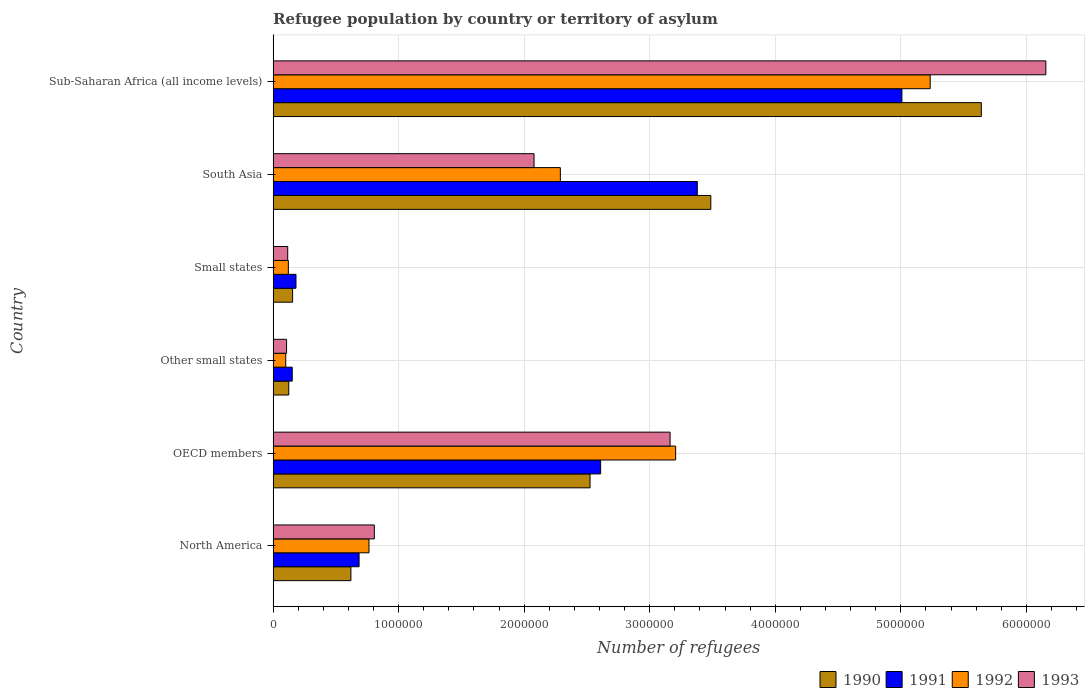How many groups of bars are there?
Your response must be concise. 6. Are the number of bars on each tick of the Y-axis equal?
Ensure brevity in your answer.  Yes. How many bars are there on the 4th tick from the top?
Offer a terse response. 4. In how many cases, is the number of bars for a given country not equal to the number of legend labels?
Keep it short and to the point. 0. What is the number of refugees in 1993 in Small states?
Offer a very short reply. 1.16e+05. Across all countries, what is the maximum number of refugees in 1993?
Provide a short and direct response. 6.16e+06. Across all countries, what is the minimum number of refugees in 1993?
Make the answer very short. 1.07e+05. In which country was the number of refugees in 1993 maximum?
Make the answer very short. Sub-Saharan Africa (all income levels). In which country was the number of refugees in 1990 minimum?
Ensure brevity in your answer.  Other small states. What is the total number of refugees in 1992 in the graph?
Offer a very short reply. 1.17e+07. What is the difference between the number of refugees in 1990 in North America and that in OECD members?
Provide a succinct answer. -1.91e+06. What is the difference between the number of refugees in 1991 in Other small states and the number of refugees in 1990 in North America?
Your response must be concise. -4.67e+05. What is the average number of refugees in 1991 per country?
Provide a short and direct response. 2.00e+06. What is the difference between the number of refugees in 1993 and number of refugees in 1992 in Sub-Saharan Africa (all income levels)?
Offer a very short reply. 9.21e+05. What is the ratio of the number of refugees in 1993 in Small states to that in South Asia?
Keep it short and to the point. 0.06. Is the number of refugees in 1993 in OECD members less than that in Small states?
Your answer should be compact. No. Is the difference between the number of refugees in 1993 in Other small states and Sub-Saharan Africa (all income levels) greater than the difference between the number of refugees in 1992 in Other small states and Sub-Saharan Africa (all income levels)?
Offer a terse response. No. What is the difference between the highest and the second highest number of refugees in 1992?
Your answer should be very brief. 2.03e+06. What is the difference between the highest and the lowest number of refugees in 1993?
Your answer should be very brief. 6.05e+06. Is the sum of the number of refugees in 1991 in Small states and Sub-Saharan Africa (all income levels) greater than the maximum number of refugees in 1993 across all countries?
Provide a short and direct response. No. What does the 3rd bar from the bottom in OECD members represents?
Offer a very short reply. 1992. Is it the case that in every country, the sum of the number of refugees in 1992 and number of refugees in 1993 is greater than the number of refugees in 1991?
Your answer should be compact. Yes. How many bars are there?
Give a very brief answer. 24. Are all the bars in the graph horizontal?
Provide a succinct answer. Yes. How many countries are there in the graph?
Offer a very short reply. 6. Does the graph contain any zero values?
Make the answer very short. No. Does the graph contain grids?
Your answer should be compact. Yes. What is the title of the graph?
Your answer should be compact. Refugee population by country or territory of asylum. Does "1998" appear as one of the legend labels in the graph?
Keep it short and to the point. No. What is the label or title of the X-axis?
Offer a terse response. Number of refugees. What is the label or title of the Y-axis?
Your answer should be very brief. Country. What is the Number of refugees in 1990 in North America?
Ensure brevity in your answer.  6.20e+05. What is the Number of refugees of 1991 in North America?
Keep it short and to the point. 6.85e+05. What is the Number of refugees of 1992 in North America?
Offer a very short reply. 7.64e+05. What is the Number of refugees in 1993 in North America?
Keep it short and to the point. 8.06e+05. What is the Number of refugees of 1990 in OECD members?
Keep it short and to the point. 2.52e+06. What is the Number of refugees in 1991 in OECD members?
Make the answer very short. 2.61e+06. What is the Number of refugees in 1992 in OECD members?
Keep it short and to the point. 3.21e+06. What is the Number of refugees in 1993 in OECD members?
Your answer should be compact. 3.16e+06. What is the Number of refugees in 1990 in Other small states?
Make the answer very short. 1.25e+05. What is the Number of refugees in 1991 in Other small states?
Offer a terse response. 1.52e+05. What is the Number of refugees of 1992 in Other small states?
Offer a very short reply. 1.00e+05. What is the Number of refugees in 1993 in Other small states?
Ensure brevity in your answer.  1.07e+05. What is the Number of refugees in 1990 in Small states?
Give a very brief answer. 1.55e+05. What is the Number of refugees in 1991 in Small states?
Your answer should be compact. 1.82e+05. What is the Number of refugees of 1992 in Small states?
Give a very brief answer. 1.21e+05. What is the Number of refugees in 1993 in Small states?
Your response must be concise. 1.16e+05. What is the Number of refugees of 1990 in South Asia?
Give a very brief answer. 3.49e+06. What is the Number of refugees in 1991 in South Asia?
Offer a very short reply. 3.38e+06. What is the Number of refugees of 1992 in South Asia?
Your answer should be compact. 2.29e+06. What is the Number of refugees in 1993 in South Asia?
Offer a terse response. 2.08e+06. What is the Number of refugees in 1990 in Sub-Saharan Africa (all income levels)?
Provide a short and direct response. 5.64e+06. What is the Number of refugees in 1991 in Sub-Saharan Africa (all income levels)?
Provide a succinct answer. 5.01e+06. What is the Number of refugees of 1992 in Sub-Saharan Africa (all income levels)?
Ensure brevity in your answer.  5.23e+06. What is the Number of refugees in 1993 in Sub-Saharan Africa (all income levels)?
Provide a short and direct response. 6.16e+06. Across all countries, what is the maximum Number of refugees in 1990?
Give a very brief answer. 5.64e+06. Across all countries, what is the maximum Number of refugees in 1991?
Give a very brief answer. 5.01e+06. Across all countries, what is the maximum Number of refugees in 1992?
Keep it short and to the point. 5.23e+06. Across all countries, what is the maximum Number of refugees of 1993?
Ensure brevity in your answer.  6.16e+06. Across all countries, what is the minimum Number of refugees in 1990?
Your response must be concise. 1.25e+05. Across all countries, what is the minimum Number of refugees of 1991?
Keep it short and to the point. 1.52e+05. Across all countries, what is the minimum Number of refugees of 1992?
Provide a succinct answer. 1.00e+05. Across all countries, what is the minimum Number of refugees of 1993?
Offer a terse response. 1.07e+05. What is the total Number of refugees in 1990 in the graph?
Make the answer very short. 1.26e+07. What is the total Number of refugees of 1991 in the graph?
Provide a short and direct response. 1.20e+07. What is the total Number of refugees of 1992 in the graph?
Offer a very short reply. 1.17e+07. What is the total Number of refugees of 1993 in the graph?
Offer a very short reply. 1.24e+07. What is the difference between the Number of refugees of 1990 in North America and that in OECD members?
Your answer should be very brief. -1.91e+06. What is the difference between the Number of refugees of 1991 in North America and that in OECD members?
Provide a succinct answer. -1.92e+06. What is the difference between the Number of refugees in 1992 in North America and that in OECD members?
Keep it short and to the point. -2.44e+06. What is the difference between the Number of refugees in 1993 in North America and that in OECD members?
Provide a short and direct response. -2.36e+06. What is the difference between the Number of refugees of 1990 in North America and that in Other small states?
Your response must be concise. 4.95e+05. What is the difference between the Number of refugees in 1991 in North America and that in Other small states?
Keep it short and to the point. 5.33e+05. What is the difference between the Number of refugees of 1992 in North America and that in Other small states?
Keep it short and to the point. 6.63e+05. What is the difference between the Number of refugees of 1993 in North America and that in Other small states?
Provide a short and direct response. 6.99e+05. What is the difference between the Number of refugees in 1990 in North America and that in Small states?
Provide a succinct answer. 4.64e+05. What is the difference between the Number of refugees in 1991 in North America and that in Small states?
Make the answer very short. 5.03e+05. What is the difference between the Number of refugees in 1992 in North America and that in Small states?
Give a very brief answer. 6.42e+05. What is the difference between the Number of refugees in 1993 in North America and that in Small states?
Your answer should be compact. 6.90e+05. What is the difference between the Number of refugees in 1990 in North America and that in South Asia?
Keep it short and to the point. -2.87e+06. What is the difference between the Number of refugees in 1991 in North America and that in South Asia?
Your response must be concise. -2.69e+06. What is the difference between the Number of refugees of 1992 in North America and that in South Asia?
Make the answer very short. -1.52e+06. What is the difference between the Number of refugees of 1993 in North America and that in South Asia?
Give a very brief answer. -1.27e+06. What is the difference between the Number of refugees of 1990 in North America and that in Sub-Saharan Africa (all income levels)?
Your answer should be very brief. -5.02e+06. What is the difference between the Number of refugees in 1991 in North America and that in Sub-Saharan Africa (all income levels)?
Provide a short and direct response. -4.32e+06. What is the difference between the Number of refugees of 1992 in North America and that in Sub-Saharan Africa (all income levels)?
Ensure brevity in your answer.  -4.47e+06. What is the difference between the Number of refugees in 1993 in North America and that in Sub-Saharan Africa (all income levels)?
Offer a very short reply. -5.35e+06. What is the difference between the Number of refugees of 1990 in OECD members and that in Other small states?
Ensure brevity in your answer.  2.40e+06. What is the difference between the Number of refugees in 1991 in OECD members and that in Other small states?
Give a very brief answer. 2.46e+06. What is the difference between the Number of refugees in 1992 in OECD members and that in Other small states?
Provide a short and direct response. 3.11e+06. What is the difference between the Number of refugees in 1993 in OECD members and that in Other small states?
Offer a terse response. 3.06e+06. What is the difference between the Number of refugees in 1990 in OECD members and that in Small states?
Provide a succinct answer. 2.37e+06. What is the difference between the Number of refugees in 1991 in OECD members and that in Small states?
Your answer should be compact. 2.43e+06. What is the difference between the Number of refugees of 1992 in OECD members and that in Small states?
Offer a terse response. 3.09e+06. What is the difference between the Number of refugees in 1993 in OECD members and that in Small states?
Make the answer very short. 3.05e+06. What is the difference between the Number of refugees in 1990 in OECD members and that in South Asia?
Make the answer very short. -9.62e+05. What is the difference between the Number of refugees in 1991 in OECD members and that in South Asia?
Your answer should be very brief. -7.70e+05. What is the difference between the Number of refugees in 1992 in OECD members and that in South Asia?
Provide a short and direct response. 9.19e+05. What is the difference between the Number of refugees in 1993 in OECD members and that in South Asia?
Ensure brevity in your answer.  1.08e+06. What is the difference between the Number of refugees in 1990 in OECD members and that in Sub-Saharan Africa (all income levels)?
Keep it short and to the point. -3.12e+06. What is the difference between the Number of refugees in 1991 in OECD members and that in Sub-Saharan Africa (all income levels)?
Give a very brief answer. -2.40e+06. What is the difference between the Number of refugees in 1992 in OECD members and that in Sub-Saharan Africa (all income levels)?
Provide a short and direct response. -2.03e+06. What is the difference between the Number of refugees of 1993 in OECD members and that in Sub-Saharan Africa (all income levels)?
Your answer should be very brief. -2.99e+06. What is the difference between the Number of refugees in 1990 in Other small states and that in Small states?
Keep it short and to the point. -3.07e+04. What is the difference between the Number of refugees of 1991 in Other small states and that in Small states?
Your response must be concise. -3.00e+04. What is the difference between the Number of refugees in 1992 in Other small states and that in Small states?
Provide a succinct answer. -2.09e+04. What is the difference between the Number of refugees in 1993 in Other small states and that in Small states?
Ensure brevity in your answer.  -9084. What is the difference between the Number of refugees of 1990 in Other small states and that in South Asia?
Your answer should be compact. -3.36e+06. What is the difference between the Number of refugees in 1991 in Other small states and that in South Asia?
Provide a succinct answer. -3.23e+06. What is the difference between the Number of refugees of 1992 in Other small states and that in South Asia?
Make the answer very short. -2.19e+06. What is the difference between the Number of refugees in 1993 in Other small states and that in South Asia?
Provide a succinct answer. -1.97e+06. What is the difference between the Number of refugees of 1990 in Other small states and that in Sub-Saharan Africa (all income levels)?
Your response must be concise. -5.52e+06. What is the difference between the Number of refugees of 1991 in Other small states and that in Sub-Saharan Africa (all income levels)?
Provide a short and direct response. -4.86e+06. What is the difference between the Number of refugees in 1992 in Other small states and that in Sub-Saharan Africa (all income levels)?
Make the answer very short. -5.13e+06. What is the difference between the Number of refugees in 1993 in Other small states and that in Sub-Saharan Africa (all income levels)?
Offer a terse response. -6.05e+06. What is the difference between the Number of refugees in 1990 in Small states and that in South Asia?
Your response must be concise. -3.33e+06. What is the difference between the Number of refugees in 1991 in Small states and that in South Asia?
Provide a succinct answer. -3.20e+06. What is the difference between the Number of refugees of 1992 in Small states and that in South Asia?
Offer a very short reply. -2.17e+06. What is the difference between the Number of refugees of 1993 in Small states and that in South Asia?
Your response must be concise. -1.96e+06. What is the difference between the Number of refugees in 1990 in Small states and that in Sub-Saharan Africa (all income levels)?
Your answer should be very brief. -5.49e+06. What is the difference between the Number of refugees in 1991 in Small states and that in Sub-Saharan Africa (all income levels)?
Provide a succinct answer. -4.83e+06. What is the difference between the Number of refugees in 1992 in Small states and that in Sub-Saharan Africa (all income levels)?
Your response must be concise. -5.11e+06. What is the difference between the Number of refugees in 1993 in Small states and that in Sub-Saharan Africa (all income levels)?
Keep it short and to the point. -6.04e+06. What is the difference between the Number of refugees in 1990 in South Asia and that in Sub-Saharan Africa (all income levels)?
Keep it short and to the point. -2.15e+06. What is the difference between the Number of refugees in 1991 in South Asia and that in Sub-Saharan Africa (all income levels)?
Offer a very short reply. -1.63e+06. What is the difference between the Number of refugees in 1992 in South Asia and that in Sub-Saharan Africa (all income levels)?
Your answer should be compact. -2.95e+06. What is the difference between the Number of refugees of 1993 in South Asia and that in Sub-Saharan Africa (all income levels)?
Keep it short and to the point. -4.08e+06. What is the difference between the Number of refugees of 1990 in North America and the Number of refugees of 1991 in OECD members?
Your answer should be very brief. -1.99e+06. What is the difference between the Number of refugees in 1990 in North America and the Number of refugees in 1992 in OECD members?
Your response must be concise. -2.59e+06. What is the difference between the Number of refugees of 1990 in North America and the Number of refugees of 1993 in OECD members?
Your answer should be compact. -2.54e+06. What is the difference between the Number of refugees in 1991 in North America and the Number of refugees in 1992 in OECD members?
Keep it short and to the point. -2.52e+06. What is the difference between the Number of refugees of 1991 in North America and the Number of refugees of 1993 in OECD members?
Provide a short and direct response. -2.48e+06. What is the difference between the Number of refugees in 1992 in North America and the Number of refugees in 1993 in OECD members?
Provide a short and direct response. -2.40e+06. What is the difference between the Number of refugees of 1990 in North America and the Number of refugees of 1991 in Other small states?
Give a very brief answer. 4.67e+05. What is the difference between the Number of refugees in 1990 in North America and the Number of refugees in 1992 in Other small states?
Provide a succinct answer. 5.19e+05. What is the difference between the Number of refugees in 1990 in North America and the Number of refugees in 1993 in Other small states?
Make the answer very short. 5.13e+05. What is the difference between the Number of refugees in 1991 in North America and the Number of refugees in 1992 in Other small states?
Your answer should be very brief. 5.84e+05. What is the difference between the Number of refugees in 1991 in North America and the Number of refugees in 1993 in Other small states?
Your response must be concise. 5.78e+05. What is the difference between the Number of refugees in 1992 in North America and the Number of refugees in 1993 in Other small states?
Keep it short and to the point. 6.57e+05. What is the difference between the Number of refugees of 1990 in North America and the Number of refugees of 1991 in Small states?
Your response must be concise. 4.37e+05. What is the difference between the Number of refugees in 1990 in North America and the Number of refugees in 1992 in Small states?
Give a very brief answer. 4.98e+05. What is the difference between the Number of refugees in 1990 in North America and the Number of refugees in 1993 in Small states?
Offer a terse response. 5.04e+05. What is the difference between the Number of refugees in 1991 in North America and the Number of refugees in 1992 in Small states?
Offer a very short reply. 5.63e+05. What is the difference between the Number of refugees in 1991 in North America and the Number of refugees in 1993 in Small states?
Provide a succinct answer. 5.69e+05. What is the difference between the Number of refugees in 1992 in North America and the Number of refugees in 1993 in Small states?
Offer a very short reply. 6.48e+05. What is the difference between the Number of refugees of 1990 in North America and the Number of refugees of 1991 in South Asia?
Offer a terse response. -2.76e+06. What is the difference between the Number of refugees of 1990 in North America and the Number of refugees of 1992 in South Asia?
Offer a terse response. -1.67e+06. What is the difference between the Number of refugees in 1990 in North America and the Number of refugees in 1993 in South Asia?
Give a very brief answer. -1.46e+06. What is the difference between the Number of refugees in 1991 in North America and the Number of refugees in 1992 in South Asia?
Offer a terse response. -1.60e+06. What is the difference between the Number of refugees of 1991 in North America and the Number of refugees of 1993 in South Asia?
Your answer should be compact. -1.39e+06. What is the difference between the Number of refugees in 1992 in North America and the Number of refugees in 1993 in South Asia?
Your answer should be compact. -1.31e+06. What is the difference between the Number of refugees of 1990 in North America and the Number of refugees of 1991 in Sub-Saharan Africa (all income levels)?
Your answer should be compact. -4.39e+06. What is the difference between the Number of refugees of 1990 in North America and the Number of refugees of 1992 in Sub-Saharan Africa (all income levels)?
Offer a very short reply. -4.61e+06. What is the difference between the Number of refugees in 1990 in North America and the Number of refugees in 1993 in Sub-Saharan Africa (all income levels)?
Provide a short and direct response. -5.54e+06. What is the difference between the Number of refugees of 1991 in North America and the Number of refugees of 1992 in Sub-Saharan Africa (all income levels)?
Offer a very short reply. -4.55e+06. What is the difference between the Number of refugees in 1991 in North America and the Number of refugees in 1993 in Sub-Saharan Africa (all income levels)?
Make the answer very short. -5.47e+06. What is the difference between the Number of refugees in 1992 in North America and the Number of refugees in 1993 in Sub-Saharan Africa (all income levels)?
Offer a terse response. -5.39e+06. What is the difference between the Number of refugees in 1990 in OECD members and the Number of refugees in 1991 in Other small states?
Your answer should be compact. 2.37e+06. What is the difference between the Number of refugees in 1990 in OECD members and the Number of refugees in 1992 in Other small states?
Provide a succinct answer. 2.42e+06. What is the difference between the Number of refugees in 1990 in OECD members and the Number of refugees in 1993 in Other small states?
Give a very brief answer. 2.42e+06. What is the difference between the Number of refugees in 1991 in OECD members and the Number of refugees in 1992 in Other small states?
Your response must be concise. 2.51e+06. What is the difference between the Number of refugees of 1991 in OECD members and the Number of refugees of 1993 in Other small states?
Provide a short and direct response. 2.50e+06. What is the difference between the Number of refugees of 1992 in OECD members and the Number of refugees of 1993 in Other small states?
Give a very brief answer. 3.10e+06. What is the difference between the Number of refugees in 1990 in OECD members and the Number of refugees in 1991 in Small states?
Give a very brief answer. 2.34e+06. What is the difference between the Number of refugees in 1990 in OECD members and the Number of refugees in 1992 in Small states?
Make the answer very short. 2.40e+06. What is the difference between the Number of refugees of 1990 in OECD members and the Number of refugees of 1993 in Small states?
Give a very brief answer. 2.41e+06. What is the difference between the Number of refugees of 1991 in OECD members and the Number of refugees of 1992 in Small states?
Your answer should be very brief. 2.49e+06. What is the difference between the Number of refugees of 1991 in OECD members and the Number of refugees of 1993 in Small states?
Give a very brief answer. 2.49e+06. What is the difference between the Number of refugees in 1992 in OECD members and the Number of refugees in 1993 in Small states?
Your answer should be compact. 3.09e+06. What is the difference between the Number of refugees in 1990 in OECD members and the Number of refugees in 1991 in South Asia?
Your answer should be very brief. -8.54e+05. What is the difference between the Number of refugees of 1990 in OECD members and the Number of refugees of 1992 in South Asia?
Offer a very short reply. 2.37e+05. What is the difference between the Number of refugees in 1990 in OECD members and the Number of refugees in 1993 in South Asia?
Ensure brevity in your answer.  4.46e+05. What is the difference between the Number of refugees in 1991 in OECD members and the Number of refugees in 1992 in South Asia?
Offer a terse response. 3.21e+05. What is the difference between the Number of refugees of 1991 in OECD members and the Number of refugees of 1993 in South Asia?
Keep it short and to the point. 5.30e+05. What is the difference between the Number of refugees in 1992 in OECD members and the Number of refugees in 1993 in South Asia?
Provide a short and direct response. 1.13e+06. What is the difference between the Number of refugees in 1990 in OECD members and the Number of refugees in 1991 in Sub-Saharan Africa (all income levels)?
Provide a short and direct response. -2.48e+06. What is the difference between the Number of refugees of 1990 in OECD members and the Number of refugees of 1992 in Sub-Saharan Africa (all income levels)?
Offer a terse response. -2.71e+06. What is the difference between the Number of refugees of 1990 in OECD members and the Number of refugees of 1993 in Sub-Saharan Africa (all income levels)?
Ensure brevity in your answer.  -3.63e+06. What is the difference between the Number of refugees of 1991 in OECD members and the Number of refugees of 1992 in Sub-Saharan Africa (all income levels)?
Offer a very short reply. -2.63e+06. What is the difference between the Number of refugees of 1991 in OECD members and the Number of refugees of 1993 in Sub-Saharan Africa (all income levels)?
Provide a succinct answer. -3.55e+06. What is the difference between the Number of refugees of 1992 in OECD members and the Number of refugees of 1993 in Sub-Saharan Africa (all income levels)?
Provide a succinct answer. -2.95e+06. What is the difference between the Number of refugees in 1990 in Other small states and the Number of refugees in 1991 in Small states?
Keep it short and to the point. -5.76e+04. What is the difference between the Number of refugees in 1990 in Other small states and the Number of refugees in 1992 in Small states?
Provide a succinct answer. 3271. What is the difference between the Number of refugees of 1990 in Other small states and the Number of refugees of 1993 in Small states?
Provide a succinct answer. 8450. What is the difference between the Number of refugees of 1991 in Other small states and the Number of refugees of 1992 in Small states?
Your answer should be very brief. 3.09e+04. What is the difference between the Number of refugees in 1991 in Other small states and the Number of refugees in 1993 in Small states?
Your answer should be very brief. 3.61e+04. What is the difference between the Number of refugees in 1992 in Other small states and the Number of refugees in 1993 in Small states?
Offer a very short reply. -1.57e+04. What is the difference between the Number of refugees in 1990 in Other small states and the Number of refugees in 1991 in South Asia?
Offer a terse response. -3.25e+06. What is the difference between the Number of refugees in 1990 in Other small states and the Number of refugees in 1992 in South Asia?
Your answer should be very brief. -2.16e+06. What is the difference between the Number of refugees of 1990 in Other small states and the Number of refugees of 1993 in South Asia?
Your answer should be very brief. -1.95e+06. What is the difference between the Number of refugees in 1991 in Other small states and the Number of refugees in 1992 in South Asia?
Offer a terse response. -2.14e+06. What is the difference between the Number of refugees in 1991 in Other small states and the Number of refugees in 1993 in South Asia?
Offer a terse response. -1.93e+06. What is the difference between the Number of refugees of 1992 in Other small states and the Number of refugees of 1993 in South Asia?
Make the answer very short. -1.98e+06. What is the difference between the Number of refugees in 1990 in Other small states and the Number of refugees in 1991 in Sub-Saharan Africa (all income levels)?
Your answer should be compact. -4.88e+06. What is the difference between the Number of refugees in 1990 in Other small states and the Number of refugees in 1992 in Sub-Saharan Africa (all income levels)?
Give a very brief answer. -5.11e+06. What is the difference between the Number of refugees in 1990 in Other small states and the Number of refugees in 1993 in Sub-Saharan Africa (all income levels)?
Offer a very short reply. -6.03e+06. What is the difference between the Number of refugees in 1991 in Other small states and the Number of refugees in 1992 in Sub-Saharan Africa (all income levels)?
Your answer should be very brief. -5.08e+06. What is the difference between the Number of refugees of 1991 in Other small states and the Number of refugees of 1993 in Sub-Saharan Africa (all income levels)?
Your response must be concise. -6.00e+06. What is the difference between the Number of refugees of 1992 in Other small states and the Number of refugees of 1993 in Sub-Saharan Africa (all income levels)?
Give a very brief answer. -6.06e+06. What is the difference between the Number of refugees of 1990 in Small states and the Number of refugees of 1991 in South Asia?
Provide a succinct answer. -3.22e+06. What is the difference between the Number of refugees in 1990 in Small states and the Number of refugees in 1992 in South Asia?
Offer a very short reply. -2.13e+06. What is the difference between the Number of refugees in 1990 in Small states and the Number of refugees in 1993 in South Asia?
Keep it short and to the point. -1.92e+06. What is the difference between the Number of refugees in 1991 in Small states and the Number of refugees in 1992 in South Asia?
Offer a very short reply. -2.11e+06. What is the difference between the Number of refugees of 1991 in Small states and the Number of refugees of 1993 in South Asia?
Provide a succinct answer. -1.90e+06. What is the difference between the Number of refugees in 1992 in Small states and the Number of refugees in 1993 in South Asia?
Your response must be concise. -1.96e+06. What is the difference between the Number of refugees in 1990 in Small states and the Number of refugees in 1991 in Sub-Saharan Africa (all income levels)?
Your answer should be very brief. -4.85e+06. What is the difference between the Number of refugees in 1990 in Small states and the Number of refugees in 1992 in Sub-Saharan Africa (all income levels)?
Offer a very short reply. -5.08e+06. What is the difference between the Number of refugees of 1990 in Small states and the Number of refugees of 1993 in Sub-Saharan Africa (all income levels)?
Make the answer very short. -6.00e+06. What is the difference between the Number of refugees of 1991 in Small states and the Number of refugees of 1992 in Sub-Saharan Africa (all income levels)?
Provide a short and direct response. -5.05e+06. What is the difference between the Number of refugees in 1991 in Small states and the Number of refugees in 1993 in Sub-Saharan Africa (all income levels)?
Provide a succinct answer. -5.97e+06. What is the difference between the Number of refugees in 1992 in Small states and the Number of refugees in 1993 in Sub-Saharan Africa (all income levels)?
Provide a short and direct response. -6.03e+06. What is the difference between the Number of refugees in 1990 in South Asia and the Number of refugees in 1991 in Sub-Saharan Africa (all income levels)?
Keep it short and to the point. -1.52e+06. What is the difference between the Number of refugees of 1990 in South Asia and the Number of refugees of 1992 in Sub-Saharan Africa (all income levels)?
Your answer should be compact. -1.75e+06. What is the difference between the Number of refugees in 1990 in South Asia and the Number of refugees in 1993 in Sub-Saharan Africa (all income levels)?
Provide a short and direct response. -2.67e+06. What is the difference between the Number of refugees in 1991 in South Asia and the Number of refugees in 1992 in Sub-Saharan Africa (all income levels)?
Keep it short and to the point. -1.86e+06. What is the difference between the Number of refugees of 1991 in South Asia and the Number of refugees of 1993 in Sub-Saharan Africa (all income levels)?
Provide a short and direct response. -2.78e+06. What is the difference between the Number of refugees in 1992 in South Asia and the Number of refugees in 1993 in Sub-Saharan Africa (all income levels)?
Your answer should be compact. -3.87e+06. What is the average Number of refugees of 1990 per country?
Give a very brief answer. 2.09e+06. What is the average Number of refugees in 1991 per country?
Offer a terse response. 2.00e+06. What is the average Number of refugees in 1992 per country?
Offer a terse response. 1.95e+06. What is the average Number of refugees in 1993 per country?
Ensure brevity in your answer.  2.07e+06. What is the difference between the Number of refugees in 1990 and Number of refugees in 1991 in North America?
Offer a very short reply. -6.52e+04. What is the difference between the Number of refugees of 1990 and Number of refugees of 1992 in North America?
Offer a terse response. -1.44e+05. What is the difference between the Number of refugees in 1990 and Number of refugees in 1993 in North America?
Your response must be concise. -1.87e+05. What is the difference between the Number of refugees of 1991 and Number of refugees of 1992 in North America?
Your response must be concise. -7.89e+04. What is the difference between the Number of refugees in 1991 and Number of refugees in 1993 in North America?
Offer a terse response. -1.22e+05. What is the difference between the Number of refugees of 1992 and Number of refugees of 1993 in North America?
Provide a short and direct response. -4.26e+04. What is the difference between the Number of refugees in 1990 and Number of refugees in 1991 in OECD members?
Provide a succinct answer. -8.42e+04. What is the difference between the Number of refugees of 1990 and Number of refugees of 1992 in OECD members?
Provide a succinct answer. -6.82e+05. What is the difference between the Number of refugees of 1990 and Number of refugees of 1993 in OECD members?
Provide a short and direct response. -6.37e+05. What is the difference between the Number of refugees in 1991 and Number of refugees in 1992 in OECD members?
Your answer should be very brief. -5.98e+05. What is the difference between the Number of refugees in 1991 and Number of refugees in 1993 in OECD members?
Keep it short and to the point. -5.53e+05. What is the difference between the Number of refugees in 1992 and Number of refugees in 1993 in OECD members?
Your response must be concise. 4.45e+04. What is the difference between the Number of refugees in 1990 and Number of refugees in 1991 in Other small states?
Keep it short and to the point. -2.76e+04. What is the difference between the Number of refugees of 1990 and Number of refugees of 1992 in Other small states?
Offer a terse response. 2.41e+04. What is the difference between the Number of refugees of 1990 and Number of refugees of 1993 in Other small states?
Offer a very short reply. 1.75e+04. What is the difference between the Number of refugees in 1991 and Number of refugees in 1992 in Other small states?
Your answer should be compact. 5.18e+04. What is the difference between the Number of refugees of 1991 and Number of refugees of 1993 in Other small states?
Your answer should be very brief. 4.52e+04. What is the difference between the Number of refugees in 1992 and Number of refugees in 1993 in Other small states?
Offer a terse response. -6604. What is the difference between the Number of refugees in 1990 and Number of refugees in 1991 in Small states?
Make the answer very short. -2.70e+04. What is the difference between the Number of refugees in 1990 and Number of refugees in 1992 in Small states?
Your response must be concise. 3.39e+04. What is the difference between the Number of refugees in 1990 and Number of refugees in 1993 in Small states?
Your answer should be compact. 3.91e+04. What is the difference between the Number of refugees of 1991 and Number of refugees of 1992 in Small states?
Provide a short and direct response. 6.09e+04. What is the difference between the Number of refugees in 1991 and Number of refugees in 1993 in Small states?
Offer a very short reply. 6.61e+04. What is the difference between the Number of refugees in 1992 and Number of refugees in 1993 in Small states?
Your answer should be compact. 5179. What is the difference between the Number of refugees in 1990 and Number of refugees in 1991 in South Asia?
Give a very brief answer. 1.08e+05. What is the difference between the Number of refugees of 1990 and Number of refugees of 1992 in South Asia?
Your response must be concise. 1.20e+06. What is the difference between the Number of refugees in 1990 and Number of refugees in 1993 in South Asia?
Provide a succinct answer. 1.41e+06. What is the difference between the Number of refugees of 1991 and Number of refugees of 1992 in South Asia?
Make the answer very short. 1.09e+06. What is the difference between the Number of refugees of 1991 and Number of refugees of 1993 in South Asia?
Ensure brevity in your answer.  1.30e+06. What is the difference between the Number of refugees in 1992 and Number of refugees in 1993 in South Asia?
Offer a very short reply. 2.10e+05. What is the difference between the Number of refugees in 1990 and Number of refugees in 1991 in Sub-Saharan Africa (all income levels)?
Offer a terse response. 6.33e+05. What is the difference between the Number of refugees of 1990 and Number of refugees of 1992 in Sub-Saharan Africa (all income levels)?
Offer a terse response. 4.07e+05. What is the difference between the Number of refugees of 1990 and Number of refugees of 1993 in Sub-Saharan Africa (all income levels)?
Your response must be concise. -5.14e+05. What is the difference between the Number of refugees in 1991 and Number of refugees in 1992 in Sub-Saharan Africa (all income levels)?
Offer a very short reply. -2.25e+05. What is the difference between the Number of refugees in 1991 and Number of refugees in 1993 in Sub-Saharan Africa (all income levels)?
Give a very brief answer. -1.15e+06. What is the difference between the Number of refugees of 1992 and Number of refugees of 1993 in Sub-Saharan Africa (all income levels)?
Your answer should be very brief. -9.21e+05. What is the ratio of the Number of refugees of 1990 in North America to that in OECD members?
Your response must be concise. 0.25. What is the ratio of the Number of refugees of 1991 in North America to that in OECD members?
Your answer should be compact. 0.26. What is the ratio of the Number of refugees in 1992 in North America to that in OECD members?
Give a very brief answer. 0.24. What is the ratio of the Number of refugees in 1993 in North America to that in OECD members?
Provide a short and direct response. 0.26. What is the ratio of the Number of refugees in 1990 in North America to that in Other small states?
Provide a succinct answer. 4.97. What is the ratio of the Number of refugees of 1991 in North America to that in Other small states?
Your response must be concise. 4.5. What is the ratio of the Number of refugees of 1992 in North America to that in Other small states?
Make the answer very short. 7.6. What is the ratio of the Number of refugees of 1993 in North America to that in Other small states?
Provide a succinct answer. 7.53. What is the ratio of the Number of refugees of 1990 in North America to that in Small states?
Provide a short and direct response. 3.99. What is the ratio of the Number of refugees of 1991 in North America to that in Small states?
Provide a succinct answer. 3.76. What is the ratio of the Number of refugees of 1992 in North America to that in Small states?
Your answer should be compact. 6.3. What is the ratio of the Number of refugees in 1993 in North America to that in Small states?
Provide a short and direct response. 6.94. What is the ratio of the Number of refugees in 1990 in North America to that in South Asia?
Your answer should be compact. 0.18. What is the ratio of the Number of refugees in 1991 in North America to that in South Asia?
Provide a short and direct response. 0.2. What is the ratio of the Number of refugees in 1992 in North America to that in South Asia?
Provide a short and direct response. 0.33. What is the ratio of the Number of refugees of 1993 in North America to that in South Asia?
Offer a very short reply. 0.39. What is the ratio of the Number of refugees of 1990 in North America to that in Sub-Saharan Africa (all income levels)?
Your answer should be very brief. 0.11. What is the ratio of the Number of refugees in 1991 in North America to that in Sub-Saharan Africa (all income levels)?
Your answer should be very brief. 0.14. What is the ratio of the Number of refugees in 1992 in North America to that in Sub-Saharan Africa (all income levels)?
Offer a terse response. 0.15. What is the ratio of the Number of refugees in 1993 in North America to that in Sub-Saharan Africa (all income levels)?
Give a very brief answer. 0.13. What is the ratio of the Number of refugees of 1990 in OECD members to that in Other small states?
Provide a succinct answer. 20.27. What is the ratio of the Number of refugees of 1991 in OECD members to that in Other small states?
Offer a very short reply. 17.14. What is the ratio of the Number of refugees in 1992 in OECD members to that in Other small states?
Make the answer very short. 31.93. What is the ratio of the Number of refugees in 1993 in OECD members to that in Other small states?
Keep it short and to the point. 29.54. What is the ratio of the Number of refugees of 1990 in OECD members to that in Small states?
Keep it short and to the point. 16.26. What is the ratio of the Number of refugees in 1991 in OECD members to that in Small states?
Your answer should be compact. 14.32. What is the ratio of the Number of refugees of 1992 in OECD members to that in Small states?
Your response must be concise. 26.43. What is the ratio of the Number of refugees in 1993 in OECD members to that in Small states?
Offer a terse response. 27.23. What is the ratio of the Number of refugees in 1990 in OECD members to that in South Asia?
Keep it short and to the point. 0.72. What is the ratio of the Number of refugees in 1991 in OECD members to that in South Asia?
Offer a terse response. 0.77. What is the ratio of the Number of refugees of 1992 in OECD members to that in South Asia?
Provide a short and direct response. 1.4. What is the ratio of the Number of refugees of 1993 in OECD members to that in South Asia?
Your response must be concise. 1.52. What is the ratio of the Number of refugees of 1990 in OECD members to that in Sub-Saharan Africa (all income levels)?
Your answer should be very brief. 0.45. What is the ratio of the Number of refugees in 1991 in OECD members to that in Sub-Saharan Africa (all income levels)?
Offer a terse response. 0.52. What is the ratio of the Number of refugees of 1992 in OECD members to that in Sub-Saharan Africa (all income levels)?
Your response must be concise. 0.61. What is the ratio of the Number of refugees of 1993 in OECD members to that in Sub-Saharan Africa (all income levels)?
Your response must be concise. 0.51. What is the ratio of the Number of refugees of 1990 in Other small states to that in Small states?
Your answer should be very brief. 0.8. What is the ratio of the Number of refugees of 1991 in Other small states to that in Small states?
Offer a very short reply. 0.84. What is the ratio of the Number of refugees in 1992 in Other small states to that in Small states?
Make the answer very short. 0.83. What is the ratio of the Number of refugees of 1993 in Other small states to that in Small states?
Offer a very short reply. 0.92. What is the ratio of the Number of refugees of 1990 in Other small states to that in South Asia?
Provide a short and direct response. 0.04. What is the ratio of the Number of refugees in 1991 in Other small states to that in South Asia?
Keep it short and to the point. 0.04. What is the ratio of the Number of refugees of 1992 in Other small states to that in South Asia?
Keep it short and to the point. 0.04. What is the ratio of the Number of refugees of 1993 in Other small states to that in South Asia?
Provide a short and direct response. 0.05. What is the ratio of the Number of refugees in 1990 in Other small states to that in Sub-Saharan Africa (all income levels)?
Keep it short and to the point. 0.02. What is the ratio of the Number of refugees of 1991 in Other small states to that in Sub-Saharan Africa (all income levels)?
Your answer should be compact. 0.03. What is the ratio of the Number of refugees of 1992 in Other small states to that in Sub-Saharan Africa (all income levels)?
Make the answer very short. 0.02. What is the ratio of the Number of refugees of 1993 in Other small states to that in Sub-Saharan Africa (all income levels)?
Your answer should be very brief. 0.02. What is the ratio of the Number of refugees in 1990 in Small states to that in South Asia?
Make the answer very short. 0.04. What is the ratio of the Number of refugees of 1991 in Small states to that in South Asia?
Ensure brevity in your answer.  0.05. What is the ratio of the Number of refugees of 1992 in Small states to that in South Asia?
Your answer should be very brief. 0.05. What is the ratio of the Number of refugees in 1993 in Small states to that in South Asia?
Keep it short and to the point. 0.06. What is the ratio of the Number of refugees of 1990 in Small states to that in Sub-Saharan Africa (all income levels)?
Make the answer very short. 0.03. What is the ratio of the Number of refugees in 1991 in Small states to that in Sub-Saharan Africa (all income levels)?
Your answer should be compact. 0.04. What is the ratio of the Number of refugees in 1992 in Small states to that in Sub-Saharan Africa (all income levels)?
Give a very brief answer. 0.02. What is the ratio of the Number of refugees of 1993 in Small states to that in Sub-Saharan Africa (all income levels)?
Provide a succinct answer. 0.02. What is the ratio of the Number of refugees of 1990 in South Asia to that in Sub-Saharan Africa (all income levels)?
Provide a short and direct response. 0.62. What is the ratio of the Number of refugees of 1991 in South Asia to that in Sub-Saharan Africa (all income levels)?
Provide a succinct answer. 0.67. What is the ratio of the Number of refugees in 1992 in South Asia to that in Sub-Saharan Africa (all income levels)?
Give a very brief answer. 0.44. What is the ratio of the Number of refugees in 1993 in South Asia to that in Sub-Saharan Africa (all income levels)?
Offer a very short reply. 0.34. What is the difference between the highest and the second highest Number of refugees in 1990?
Ensure brevity in your answer.  2.15e+06. What is the difference between the highest and the second highest Number of refugees of 1991?
Give a very brief answer. 1.63e+06. What is the difference between the highest and the second highest Number of refugees in 1992?
Your answer should be very brief. 2.03e+06. What is the difference between the highest and the second highest Number of refugees of 1993?
Your answer should be very brief. 2.99e+06. What is the difference between the highest and the lowest Number of refugees in 1990?
Your answer should be very brief. 5.52e+06. What is the difference between the highest and the lowest Number of refugees in 1991?
Make the answer very short. 4.86e+06. What is the difference between the highest and the lowest Number of refugees of 1992?
Your answer should be compact. 5.13e+06. What is the difference between the highest and the lowest Number of refugees in 1993?
Provide a short and direct response. 6.05e+06. 